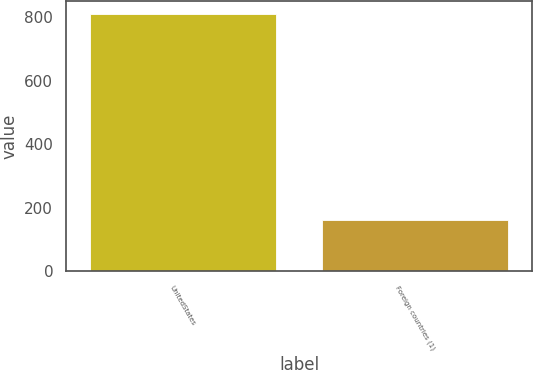Convert chart to OTSL. <chart><loc_0><loc_0><loc_500><loc_500><bar_chart><fcel>UnitedStates<fcel>Foreign countries (1)<nl><fcel>811<fcel>162<nl></chart> 